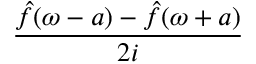Convert formula to latex. <formula><loc_0><loc_0><loc_500><loc_500>\frac { { \hat { f } } ( \omega - a ) - { \hat { f } } ( \omega + a ) } { 2 i }</formula> 